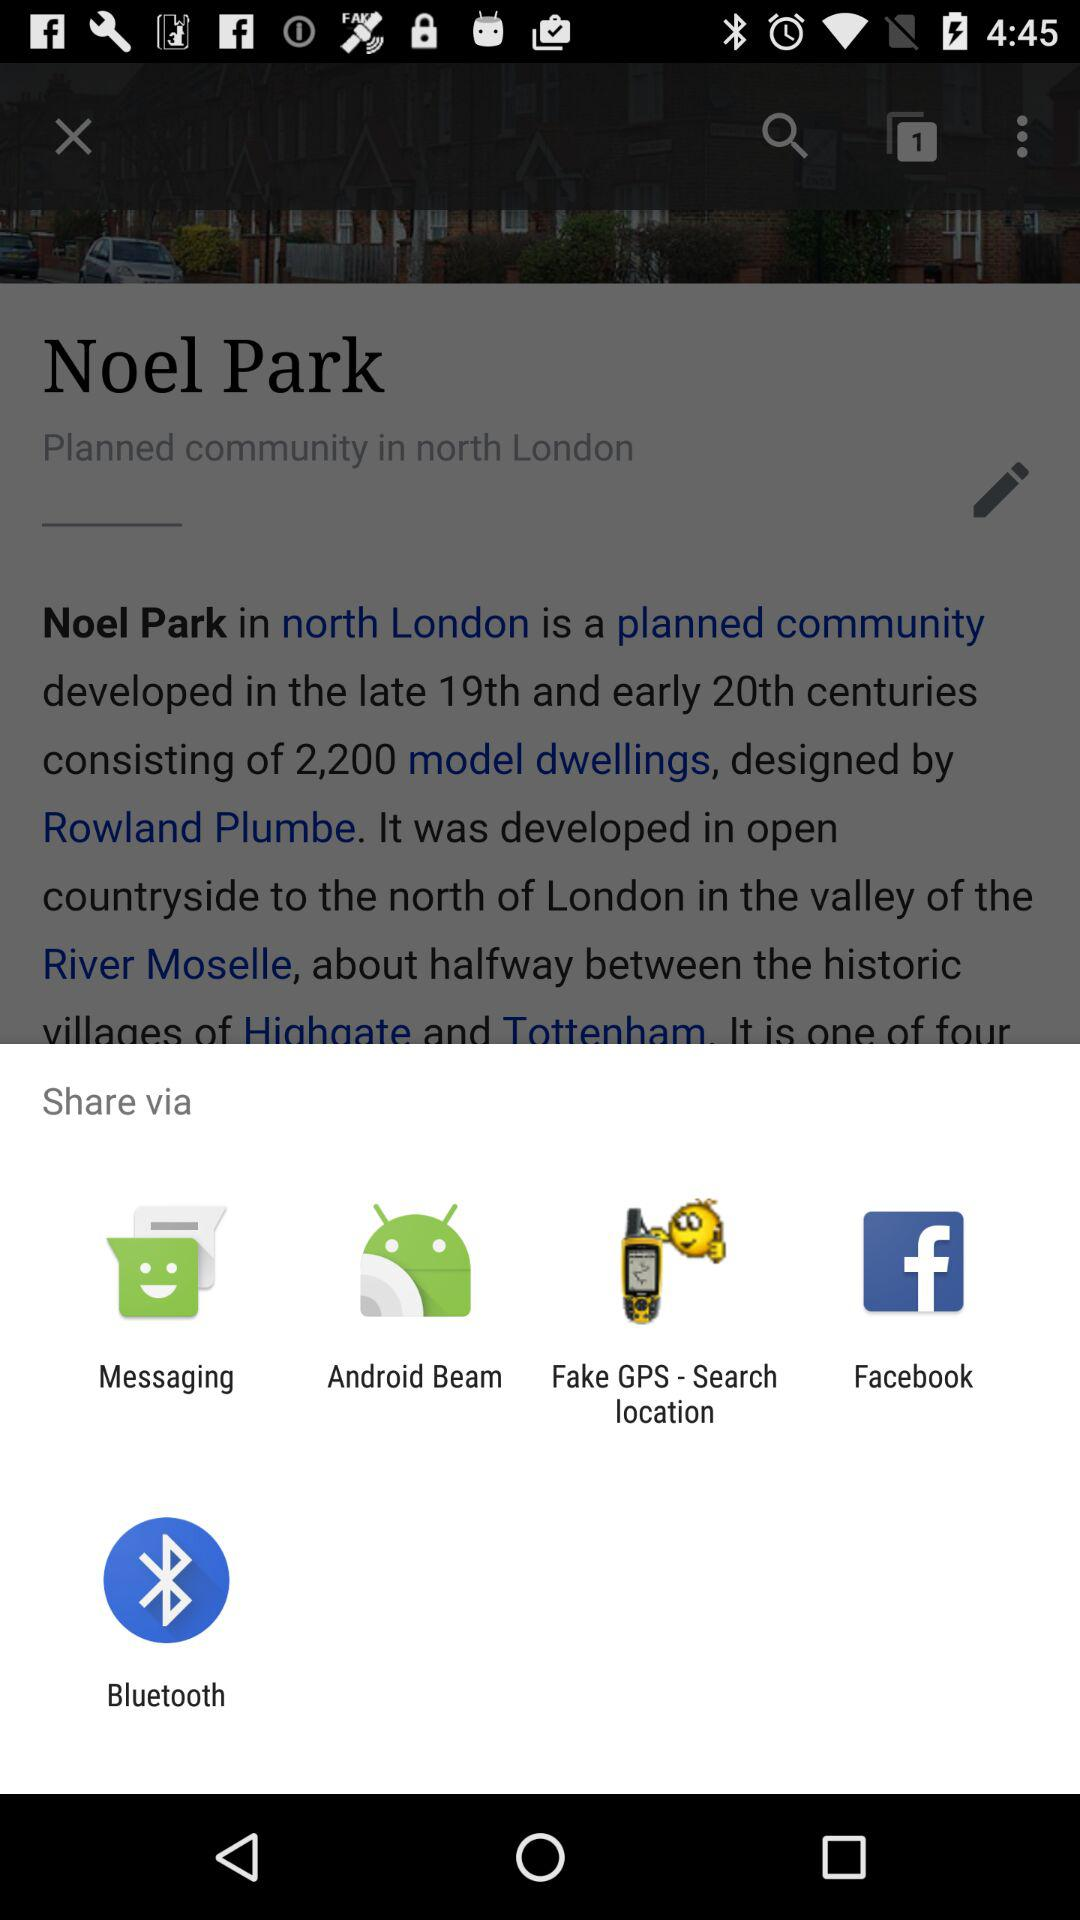How many number of model dwellings are there? There are 2,200 model dwellings. 